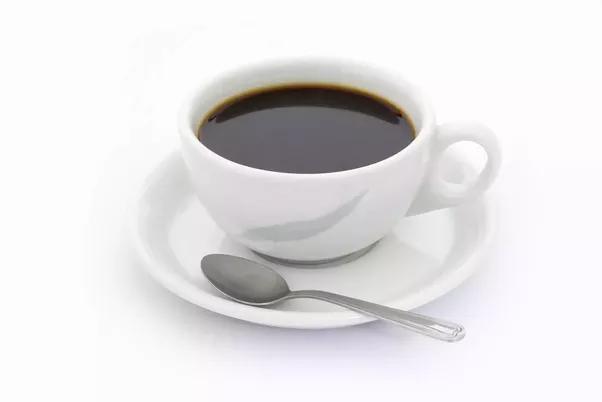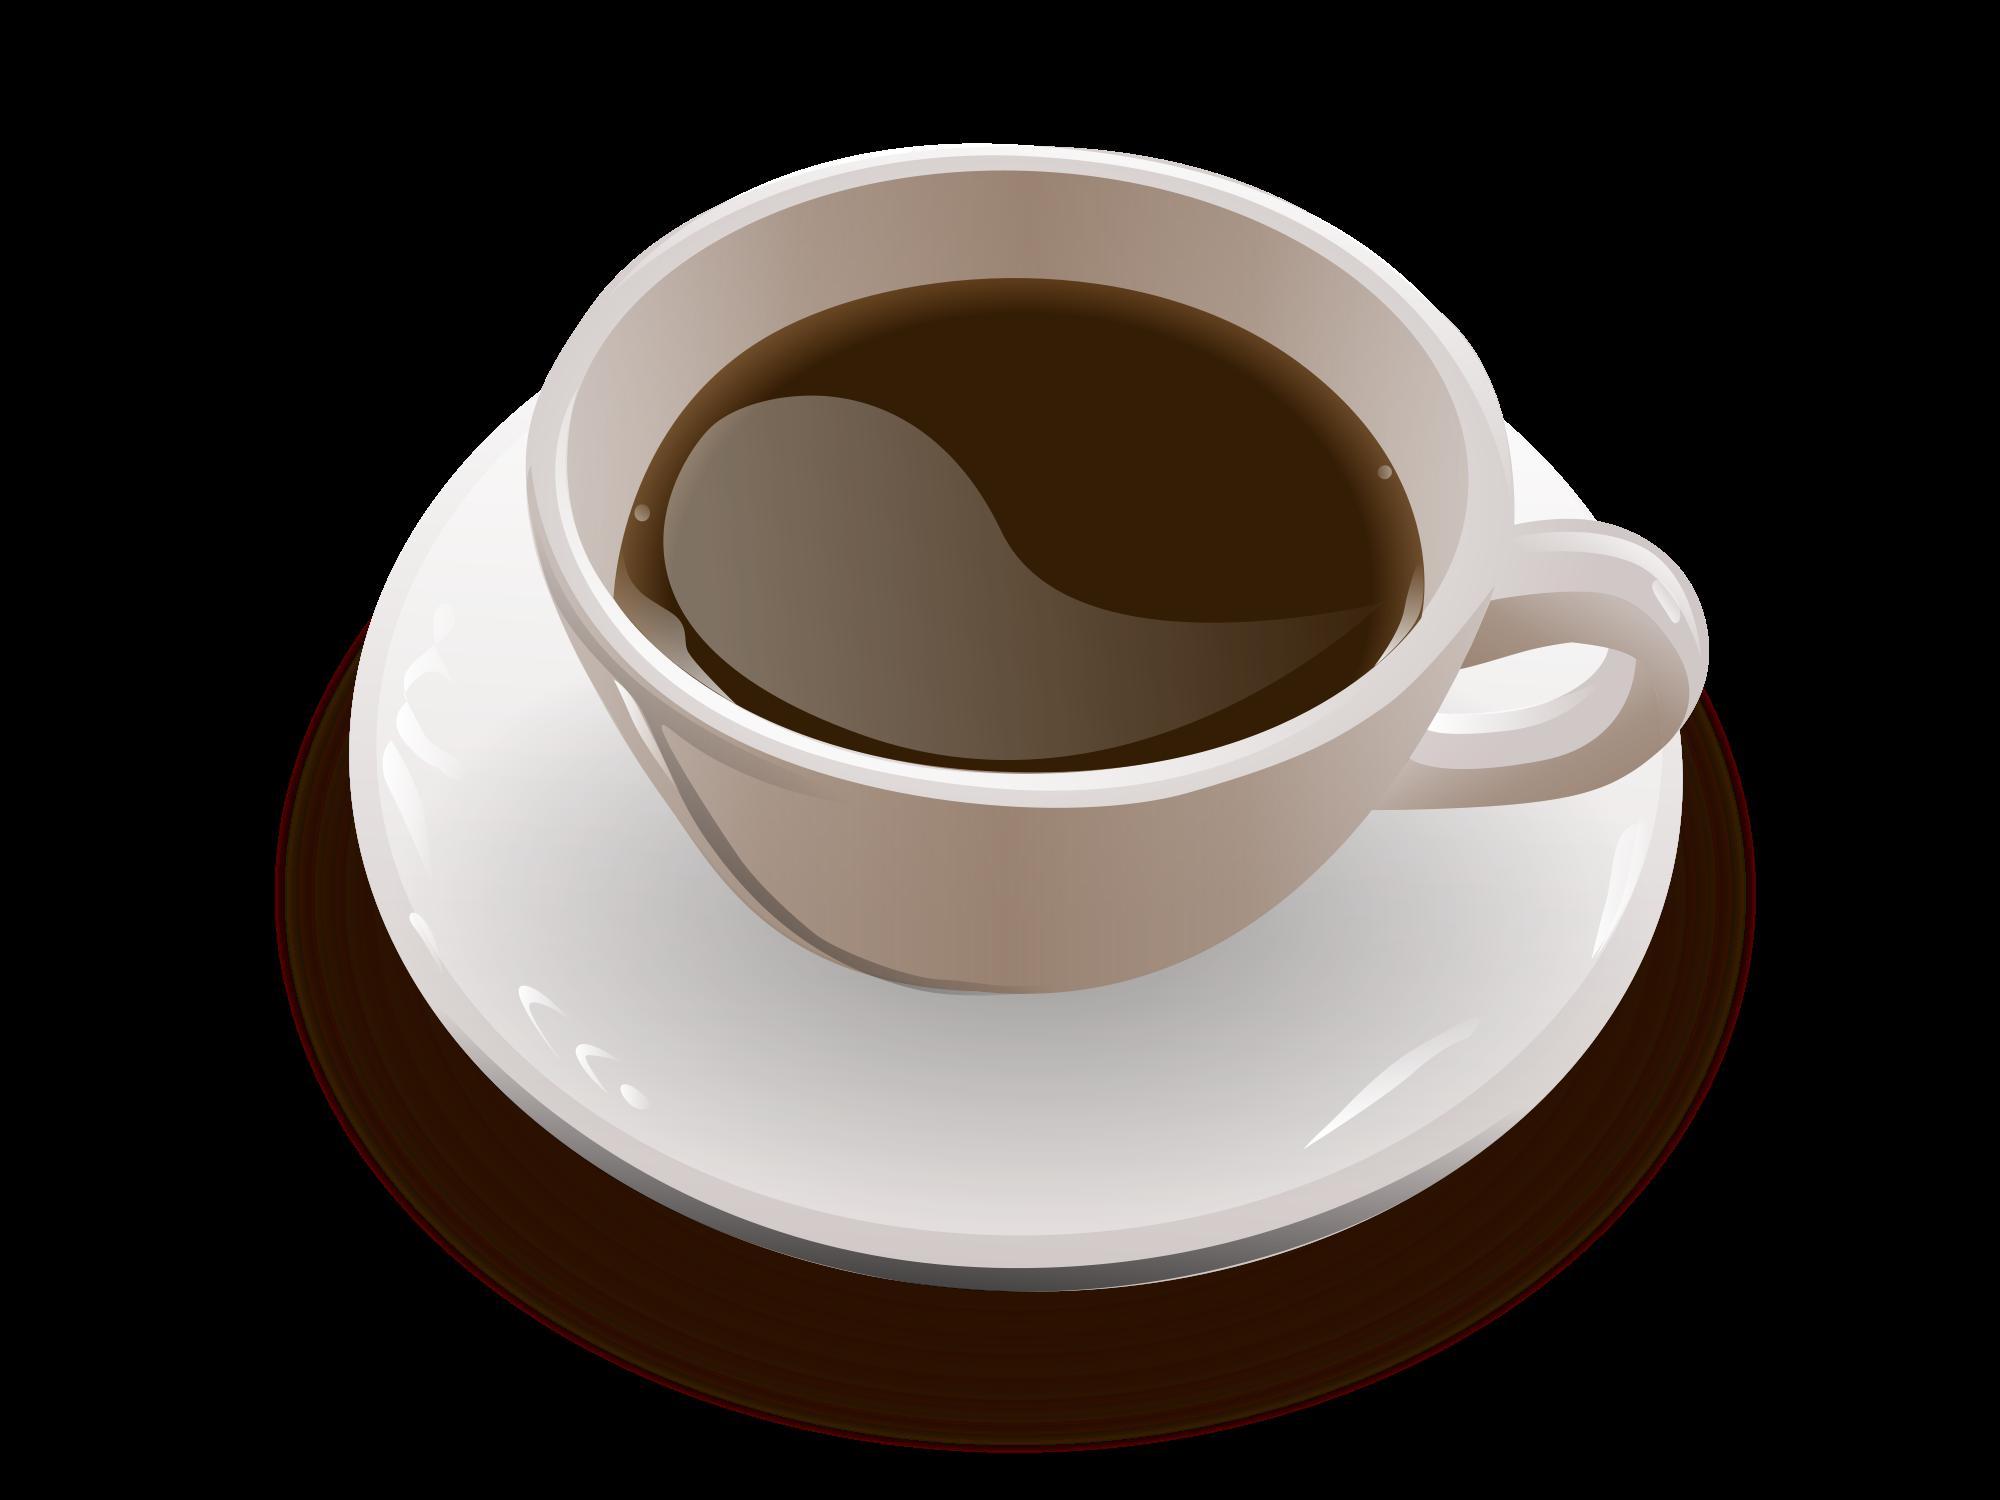The first image is the image on the left, the second image is the image on the right. For the images displayed, is the sentence "In one image, there is no spoon laid next to the cup on the plate." factually correct? Answer yes or no. Yes. The first image is the image on the left, the second image is the image on the right. Assess this claim about the two images: "Full cups of coffee sit on matching saucers with a spoon.". Correct or not? Answer yes or no. No. 